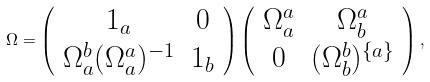Convert formula to latex. <formula><loc_0><loc_0><loc_500><loc_500>\Omega = \left ( \begin{array} { c c } { 1 } _ { a } & 0 \\ \Omega ^ { b } _ { a } ( \Omega ^ { a } _ { a } ) ^ { - 1 } & 1 _ { b } \end{array} \right ) \left ( \begin{array} { c c } \Omega ^ { a } _ { a } & \Omega ^ { a } _ { b } \\ 0 & ( \Omega ^ { b } _ { b } ) ^ { \{ a \} } \end{array} \right ) ,</formula> 